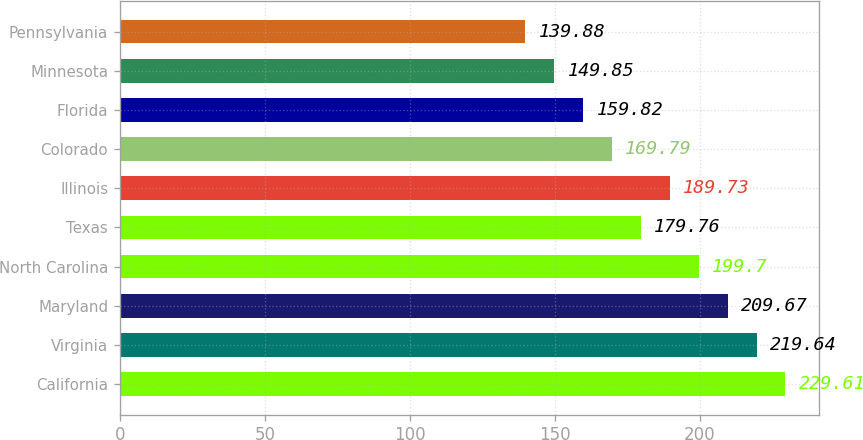Convert chart to OTSL. <chart><loc_0><loc_0><loc_500><loc_500><bar_chart><fcel>California<fcel>Virginia<fcel>Maryland<fcel>North Carolina<fcel>Texas<fcel>Illinois<fcel>Colorado<fcel>Florida<fcel>Minnesota<fcel>Pennsylvania<nl><fcel>229.61<fcel>219.64<fcel>209.67<fcel>199.7<fcel>179.76<fcel>189.73<fcel>169.79<fcel>159.82<fcel>149.85<fcel>139.88<nl></chart> 